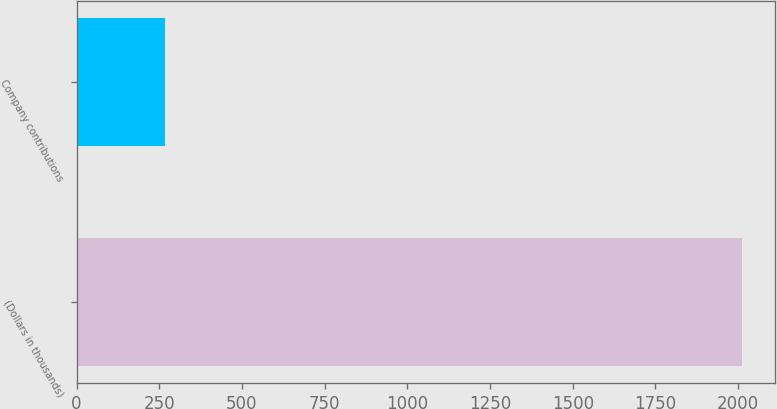<chart> <loc_0><loc_0><loc_500><loc_500><bar_chart><fcel>(Dollars in thousands)<fcel>Company contributions<nl><fcel>2012<fcel>267<nl></chart> 